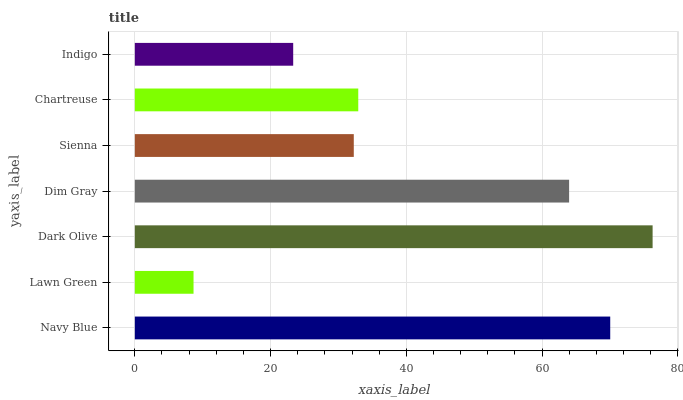Is Lawn Green the minimum?
Answer yes or no. Yes. Is Dark Olive the maximum?
Answer yes or no. Yes. Is Dark Olive the minimum?
Answer yes or no. No. Is Lawn Green the maximum?
Answer yes or no. No. Is Dark Olive greater than Lawn Green?
Answer yes or no. Yes. Is Lawn Green less than Dark Olive?
Answer yes or no. Yes. Is Lawn Green greater than Dark Olive?
Answer yes or no. No. Is Dark Olive less than Lawn Green?
Answer yes or no. No. Is Chartreuse the high median?
Answer yes or no. Yes. Is Chartreuse the low median?
Answer yes or no. Yes. Is Navy Blue the high median?
Answer yes or no. No. Is Indigo the low median?
Answer yes or no. No. 